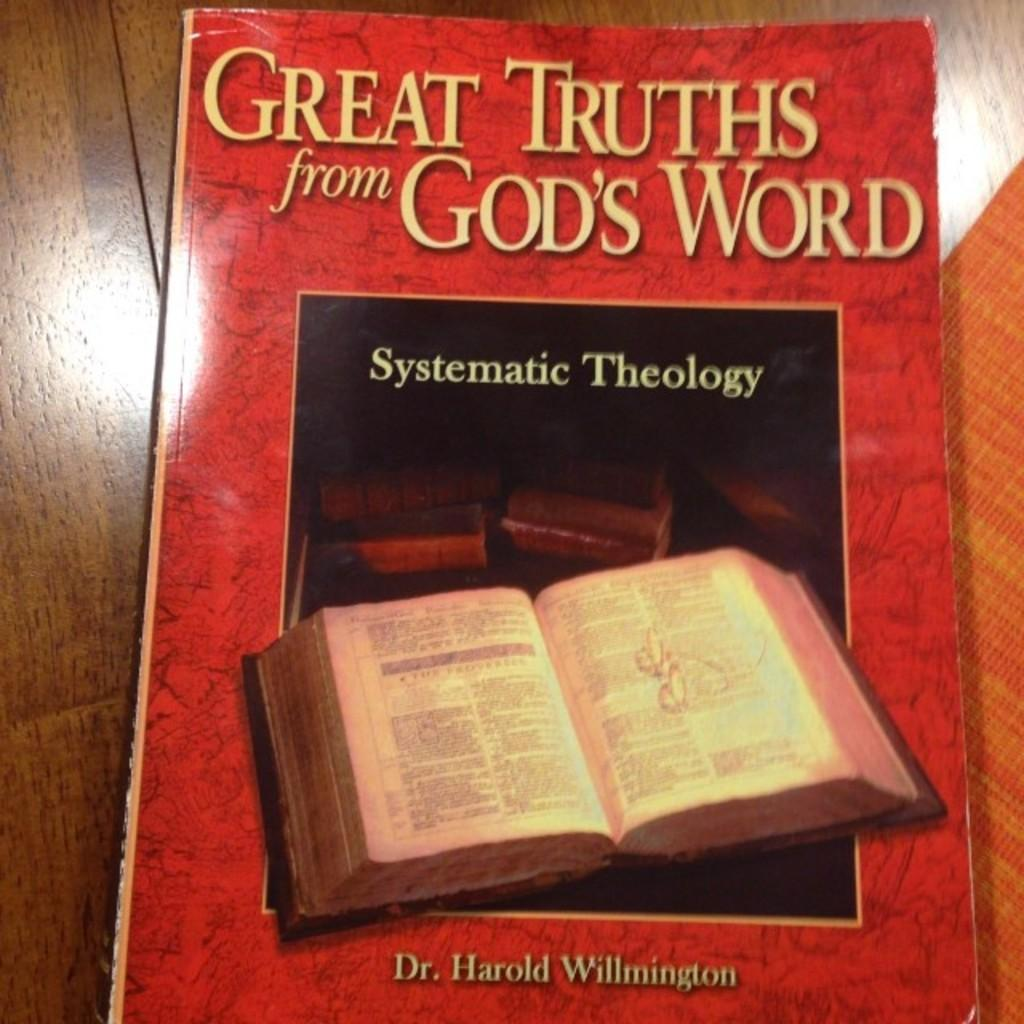Provide a one-sentence caption for the provided image. A book explores the religious discipline known as systematic theology. 